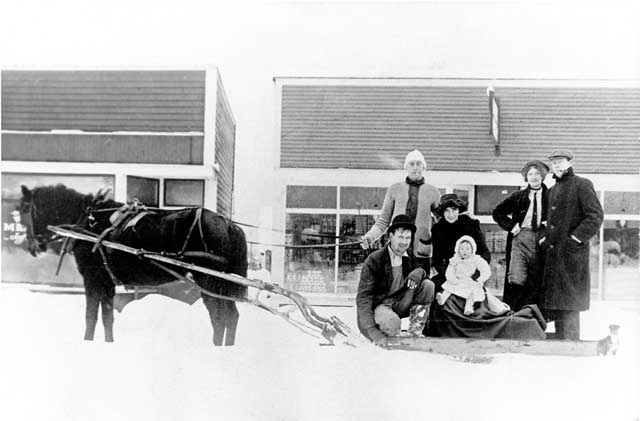Describe the objects in this image and their specific colors. I can see horse in white, black, gray, darkgray, and lightgray tones, people in white, black, gray, darkgray, and lightgray tones, people in white, black, gray, darkgray, and lightgray tones, people in white, black, gray, darkgray, and lightgray tones, and people in white, darkgray, gray, lightgray, and black tones in this image. 